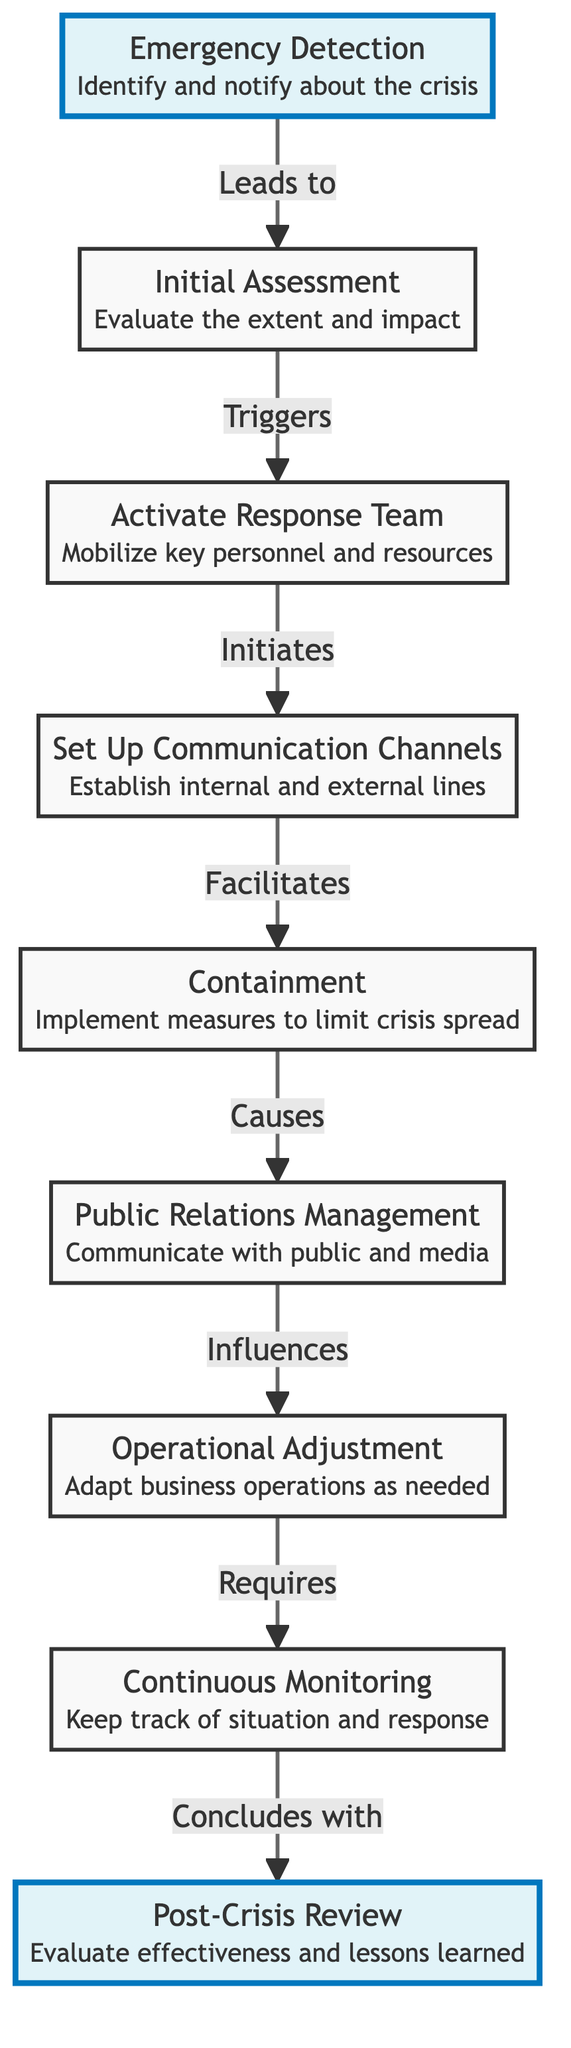What is the first step in the crisis response plan? The first step, as indicated at the top of the diagram, is "Emergency Detection". This involves identifying and notifying about the crisis.
Answer: Emergency Detection How many total steps are shown in the diagram? By counting all the nodes in the diagram, there are a total of nine steps in the crisis response plan.
Answer: Nine What connects "Initial Assessment" and "Activate Response Team"? The relationship between "Initial Assessment" and "Activate Response Team" is described as "Triggers", indicating that the former step directly leads to the latter.
Answer: Triggers What is the key action after "Public Relations Management"? The step that follows "Public Relations Management" is "Operational Adjustment", meaning adjustments to business operations need to be made next.
Answer: Operational Adjustment Which step requires "Continuous Monitoring"? "Operational Adjustment" is the step that requires "Continuous Monitoring" as per the flow of the diagram, indicating that ongoing evaluations are essential after adjustments are made.
Answer: Continuous Monitoring What is the final step in the crisis response plan? The last node in the diagram is "Post-Crisis Review", which emphasizes the evaluation of effectiveness and lessons learned after the crisis has been managed.
Answer: Post-Crisis Review Which action has a direct influence on public relations management? The action that influences "Public Relations Management" is "Containment", meaning efforts to limit the crisis spread directly affect how communication is managed with the public and media.
Answer: Containment What does "Set Up Communication Channels" facilitate? "Set Up Communication Channels" facilitates "Containment", which implies that establishing clear communication is critical for implementing measures to control the crisis.
Answer: Containment What is indicated by the bold styling of "Emergency Detection" and "Post-Crisis Review"? The bold styling of "Emergency Detection" and "Post-Crisis Review" in the diagram signifies their importance as starting and concluding points in the crisis response process.
Answer: Importance 